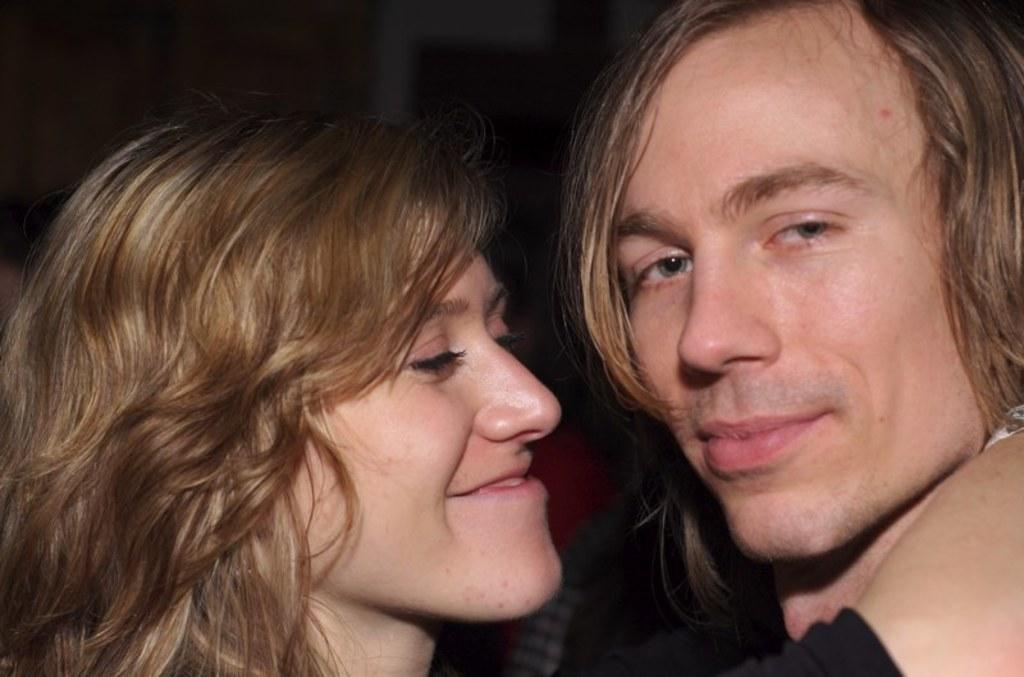How many individuals are present in the image? There are two people in the image. What can be observed about the background of the image? The background of the image is dark. What type of prose is being written by the people in the image? There is no indication in the image that the people are writing any prose, as their actions or expressions are not visible. 